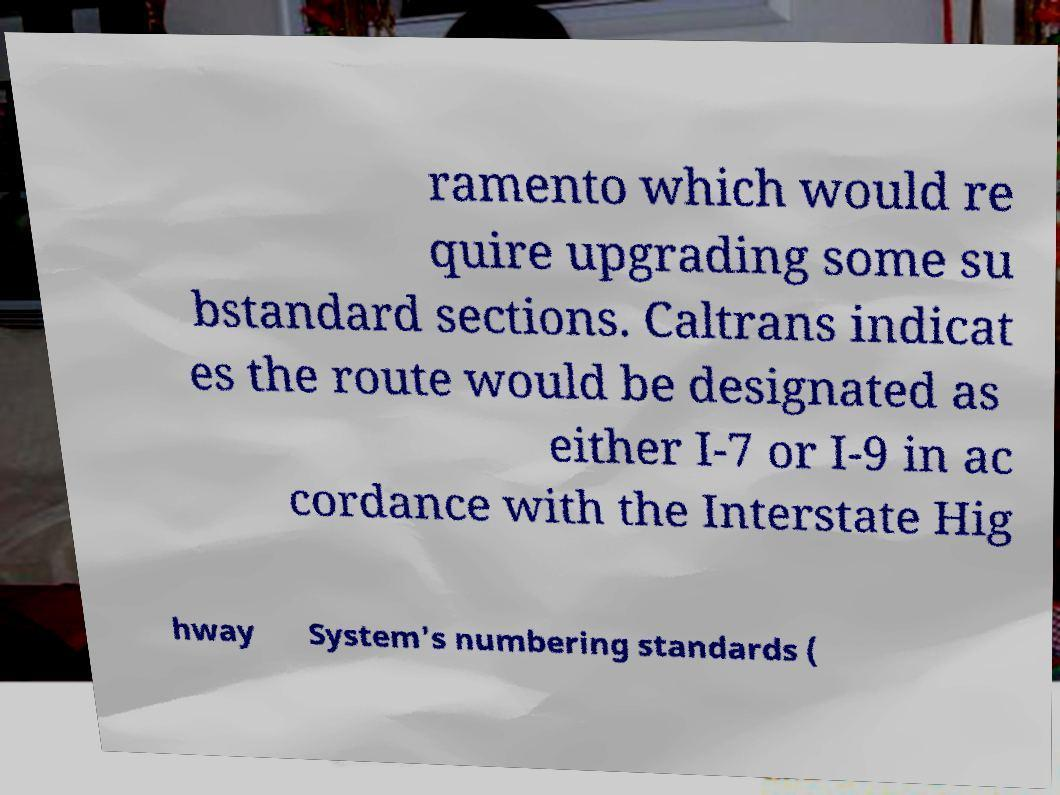Can you accurately transcribe the text from the provided image for me? ramento which would re quire upgrading some su bstandard sections. Caltrans indicat es the route would be designated as either I-7 or I-9 in ac cordance with the Interstate Hig hway System's numbering standards ( 